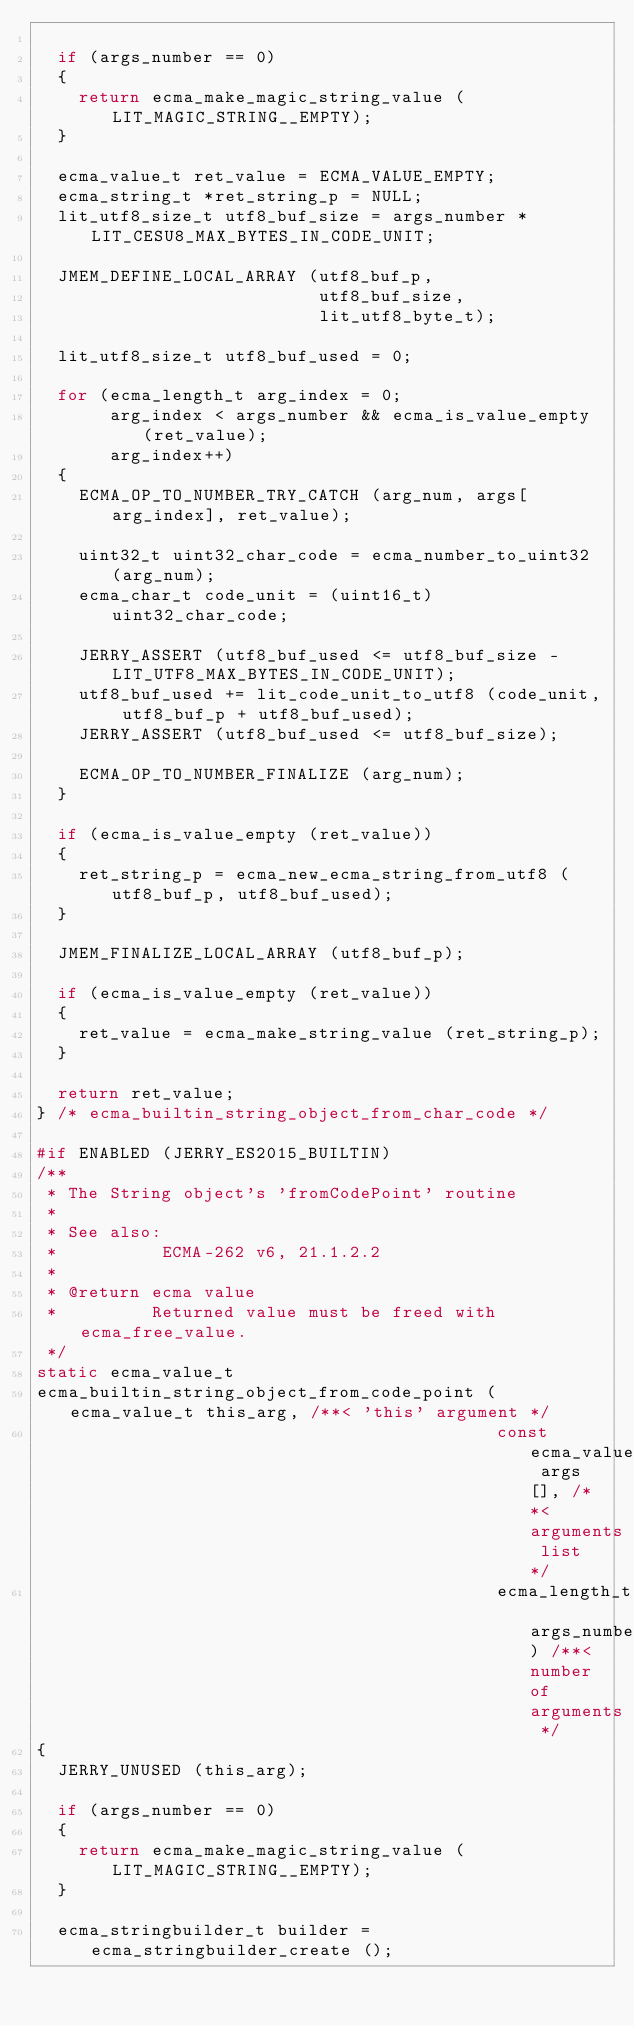Convert code to text. <code><loc_0><loc_0><loc_500><loc_500><_C_>
  if (args_number == 0)
  {
    return ecma_make_magic_string_value (LIT_MAGIC_STRING__EMPTY);
  }

  ecma_value_t ret_value = ECMA_VALUE_EMPTY;
  ecma_string_t *ret_string_p = NULL;
  lit_utf8_size_t utf8_buf_size = args_number * LIT_CESU8_MAX_BYTES_IN_CODE_UNIT;

  JMEM_DEFINE_LOCAL_ARRAY (utf8_buf_p,
                           utf8_buf_size,
                           lit_utf8_byte_t);

  lit_utf8_size_t utf8_buf_used = 0;

  for (ecma_length_t arg_index = 0;
       arg_index < args_number && ecma_is_value_empty (ret_value);
       arg_index++)
  {
    ECMA_OP_TO_NUMBER_TRY_CATCH (arg_num, args[arg_index], ret_value);

    uint32_t uint32_char_code = ecma_number_to_uint32 (arg_num);
    ecma_char_t code_unit = (uint16_t) uint32_char_code;

    JERRY_ASSERT (utf8_buf_used <= utf8_buf_size - LIT_UTF8_MAX_BYTES_IN_CODE_UNIT);
    utf8_buf_used += lit_code_unit_to_utf8 (code_unit, utf8_buf_p + utf8_buf_used);
    JERRY_ASSERT (utf8_buf_used <= utf8_buf_size);

    ECMA_OP_TO_NUMBER_FINALIZE (arg_num);
  }

  if (ecma_is_value_empty (ret_value))
  {
    ret_string_p = ecma_new_ecma_string_from_utf8 (utf8_buf_p, utf8_buf_used);
  }

  JMEM_FINALIZE_LOCAL_ARRAY (utf8_buf_p);

  if (ecma_is_value_empty (ret_value))
  {
    ret_value = ecma_make_string_value (ret_string_p);
  }

  return ret_value;
} /* ecma_builtin_string_object_from_char_code */

#if ENABLED (JERRY_ES2015_BUILTIN)
/**
 * The String object's 'fromCodePoint' routine
 *
 * See also:
 *          ECMA-262 v6, 21.1.2.2
 *
 * @return ecma value
 *         Returned value must be freed with ecma_free_value.
 */
static ecma_value_t
ecma_builtin_string_object_from_code_point (ecma_value_t this_arg, /**< 'this' argument */
                                            const ecma_value_t args[], /**< arguments list */
                                            ecma_length_t args_number) /**< number of arguments */
{
  JERRY_UNUSED (this_arg);

  if (args_number == 0)
  {
    return ecma_make_magic_string_value (LIT_MAGIC_STRING__EMPTY);
  }

  ecma_stringbuilder_t builder = ecma_stringbuilder_create ();
</code> 